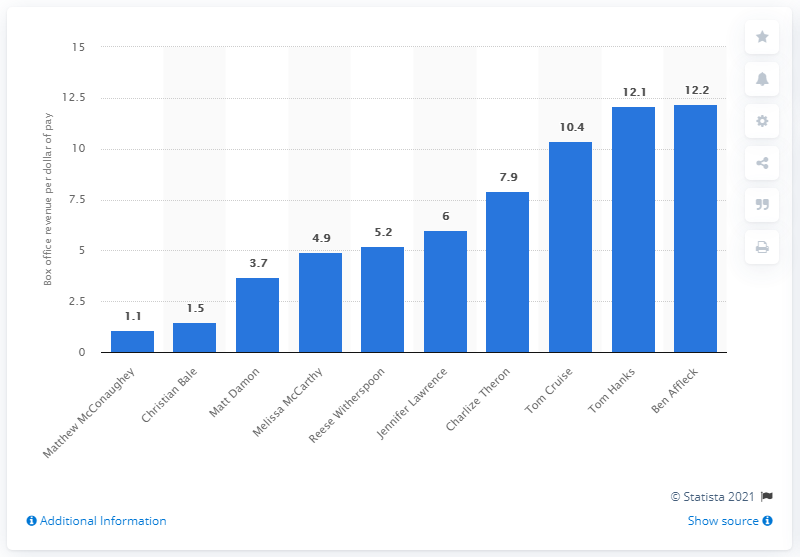Which actor is shown highest on the list? Ben Affleck and Tom Hanks are tied at the top of the list, each generating $12.2 per dollar paid. 